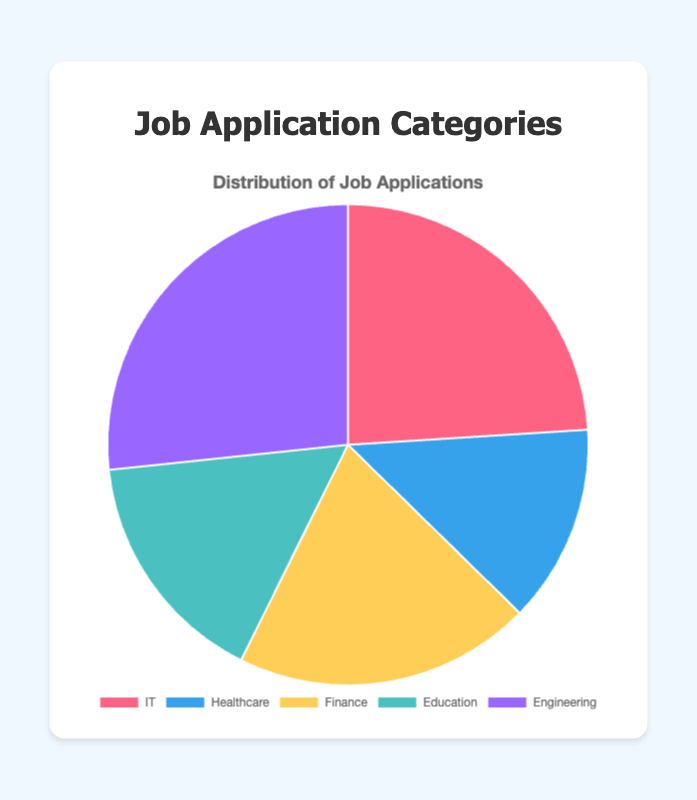What percentage of job applications were sent to the Engineering category? To find the percentage, divide the number of Engineering applications by the total number of applications and multiply by 100. The total applications = 18+10+15+12+20 = 75. The percentage for Engineering is (20/75) * 100 = approximately 26.67%.
Answer: 26.67% Which category has the least number of job applications sent out? By examining the data points, Healthcare has 10 applications, which is the lowest among all categories.
Answer: Healthcare How many more applications were sent to the IT category compared to the Education category? Subtract the number of applications sent to Education from those sent to IT. IT applications = 18, Education applications = 12, the difference is 18 - 12 = 6.
Answer: 6 Rank the categories from the highest to the lowest number of job applications sent out. Sorting the categories based on the number of applications: Engineering (20), IT (18), Finance (15), Education (12), Healthcare (10).
Answer: Engineering, IT, Finance, Education, Healthcare What is the mean number of job applications sent across all categories? Sum the total number of applications and divide by the number of categories. Total applications = 75, number of categories = 5, so the mean is 75/5 = 15.
Answer: 15 Which sector received the second highest number of job applications? By ranking the sectors, the highest is Engineering with 20 applications, the second highest is IT with 18 applications.
Answer: IT Are there any categories with equal numbers of job applications? Upon examining the data, no two categories have the same number of applications sent out.
Answer: No What is the combined total of applications sent to the Healthcare and Finance categories? Add the number of applications for Healthcare and Finance. Healthcare = 10, Finance = 15, combined total = 10 + 15 = 25.
Answer: 25 What proportion of job applications were sent to the Finance category out of the total? Divide the number of Finance applications by the total number of applications and convert to a proportion. Finance = 15, total = 75, proportion = 15/75 = 1/5 or 0.20.
Answer: 0.20 